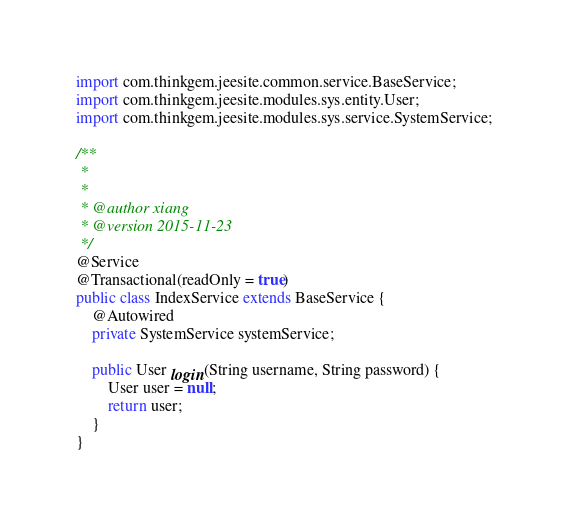Convert code to text. <code><loc_0><loc_0><loc_500><loc_500><_Java_>
import com.thinkgem.jeesite.common.service.BaseService;
import com.thinkgem.jeesite.modules.sys.entity.User;
import com.thinkgem.jeesite.modules.sys.service.SystemService;

/**
 * 
 * 
 * @author xiang
 * @version 2015-11-23
 */
@Service
@Transactional(readOnly = true)
public class IndexService extends BaseService {
	@Autowired
	private SystemService systemService;

	public User login(String username, String password) {
		User user = null;
		return user;
	}
}</code> 